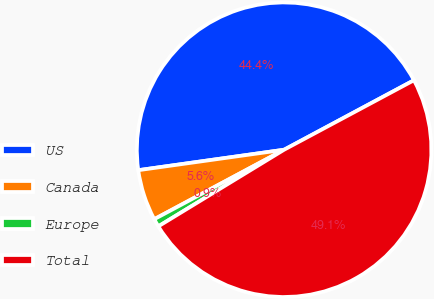<chart> <loc_0><loc_0><loc_500><loc_500><pie_chart><fcel>US<fcel>Canada<fcel>Europe<fcel>Total<nl><fcel>44.4%<fcel>5.6%<fcel>0.89%<fcel>49.11%<nl></chart> 